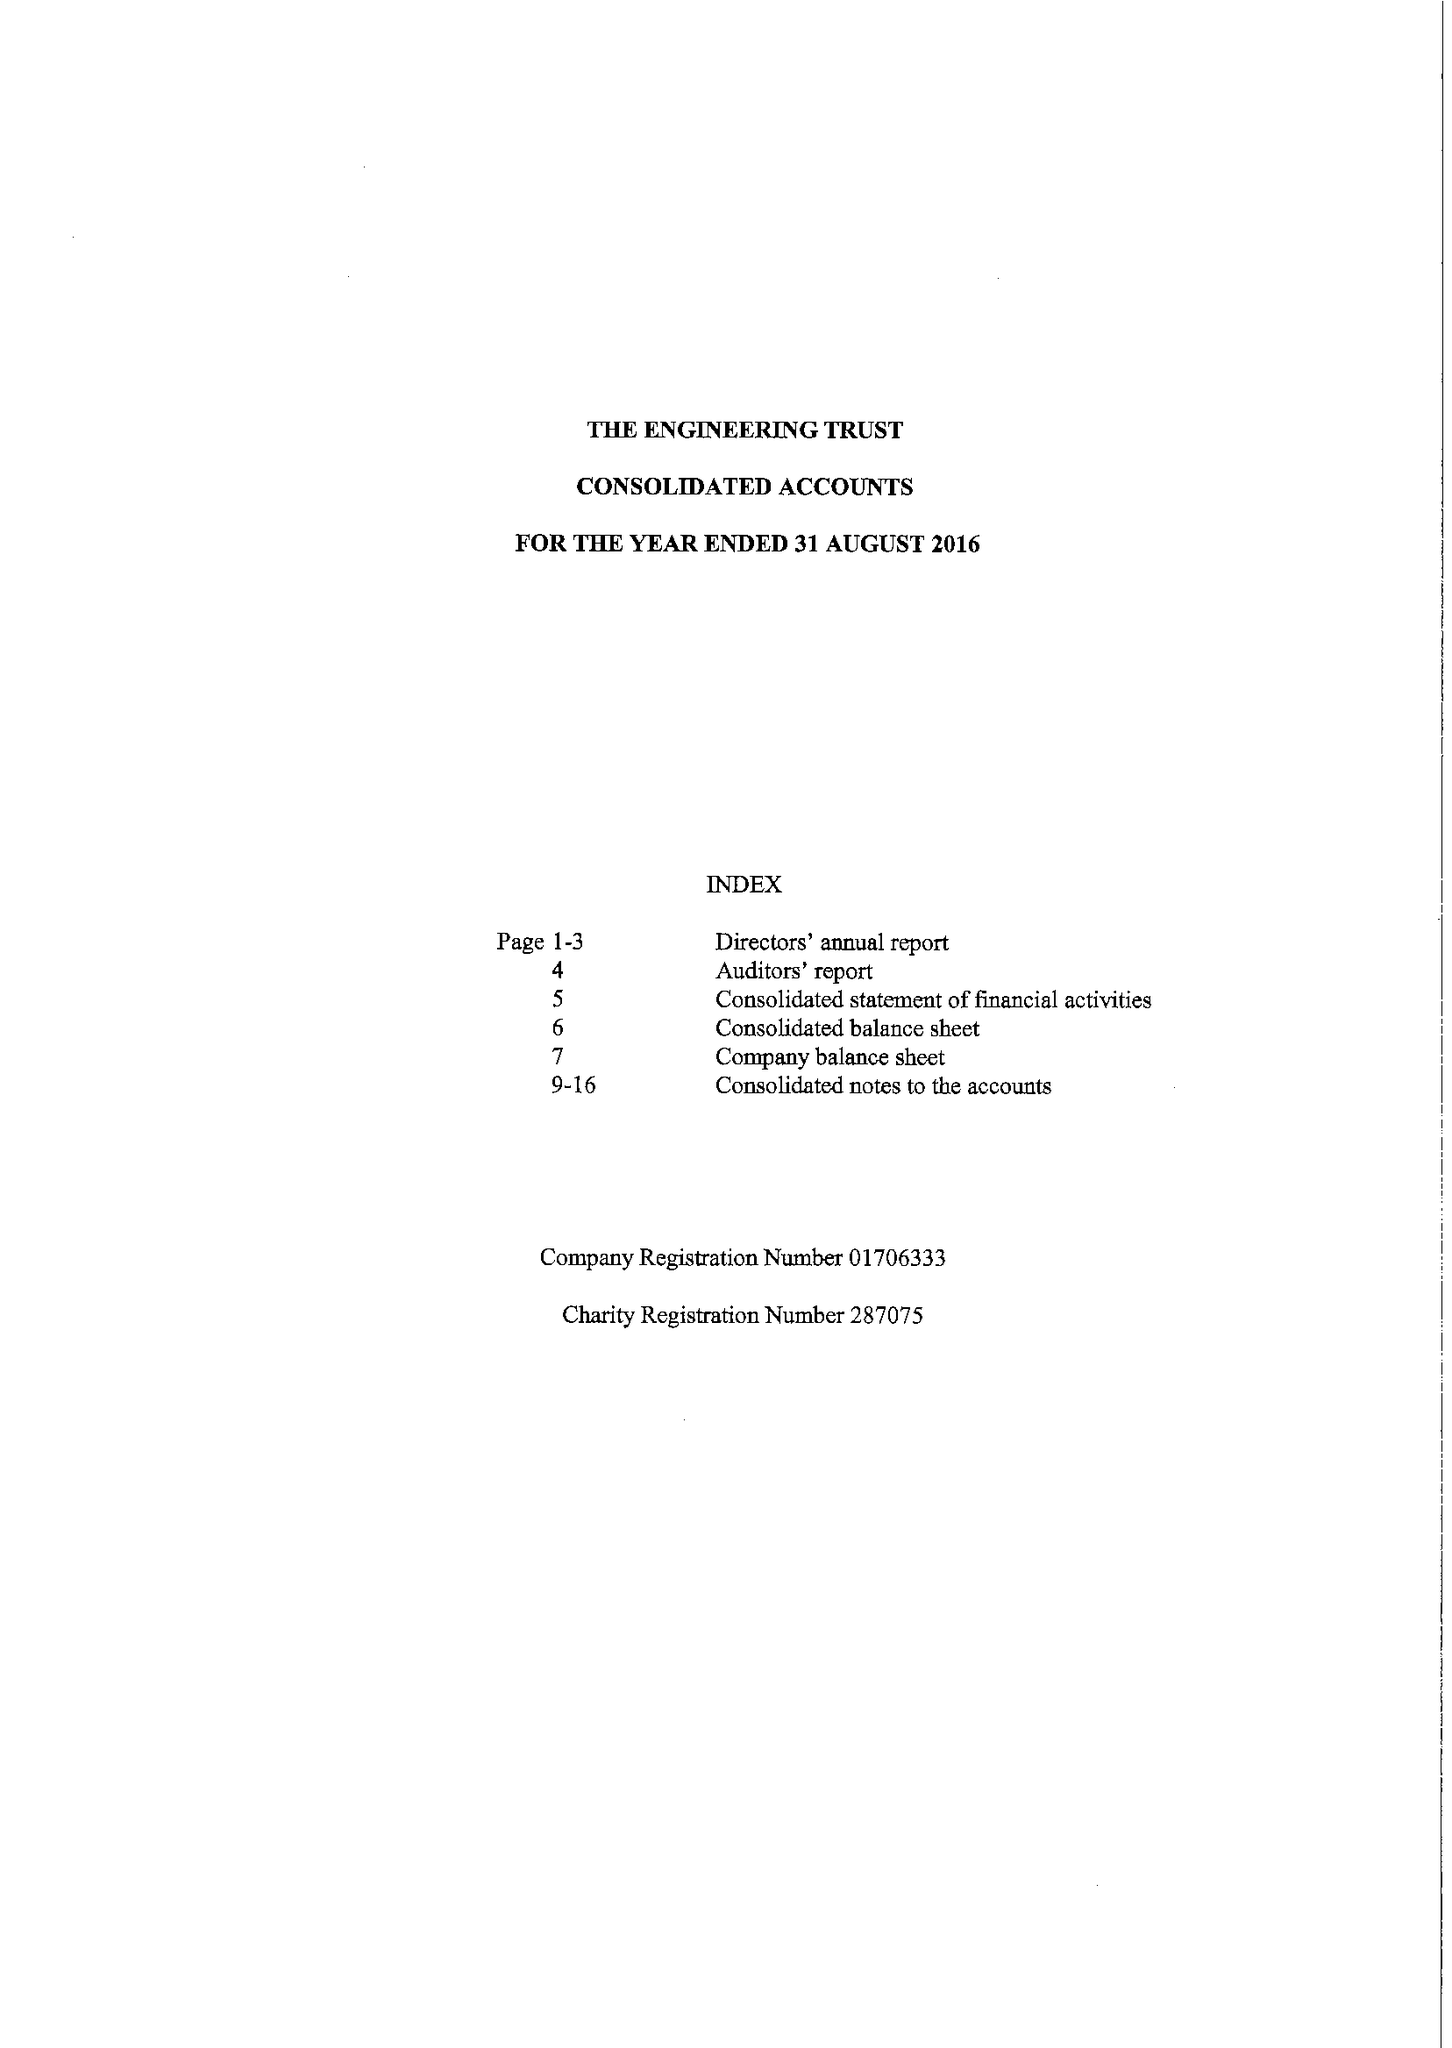What is the value for the income_annually_in_british_pounds?
Answer the question using a single word or phrase. 95858.00 